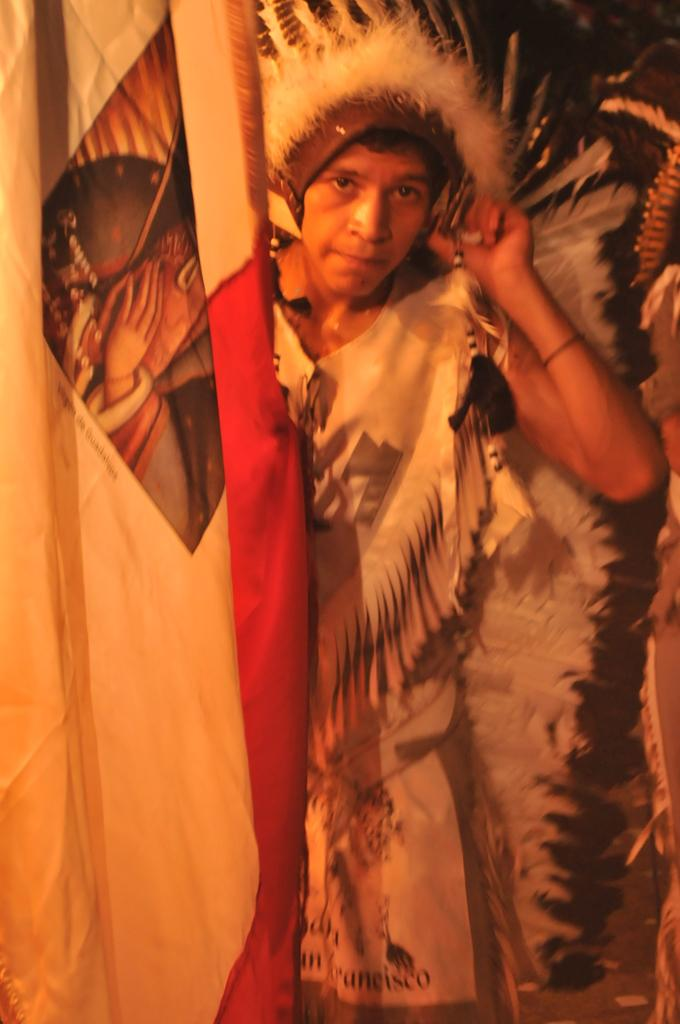Who is present in the image? There is a woman in the image. What is the woman wearing? The woman is wearing a white and black costume. What is the woman doing in the image? The woman is standing. What can be seen on the left side of the image? There is a sheet or a cloth in white and red color on the left side of the image. What type of collar is the horse wearing in the image? There is no horse present in the image, so it is not possible to determine what type of collar the horse might be wearing. 